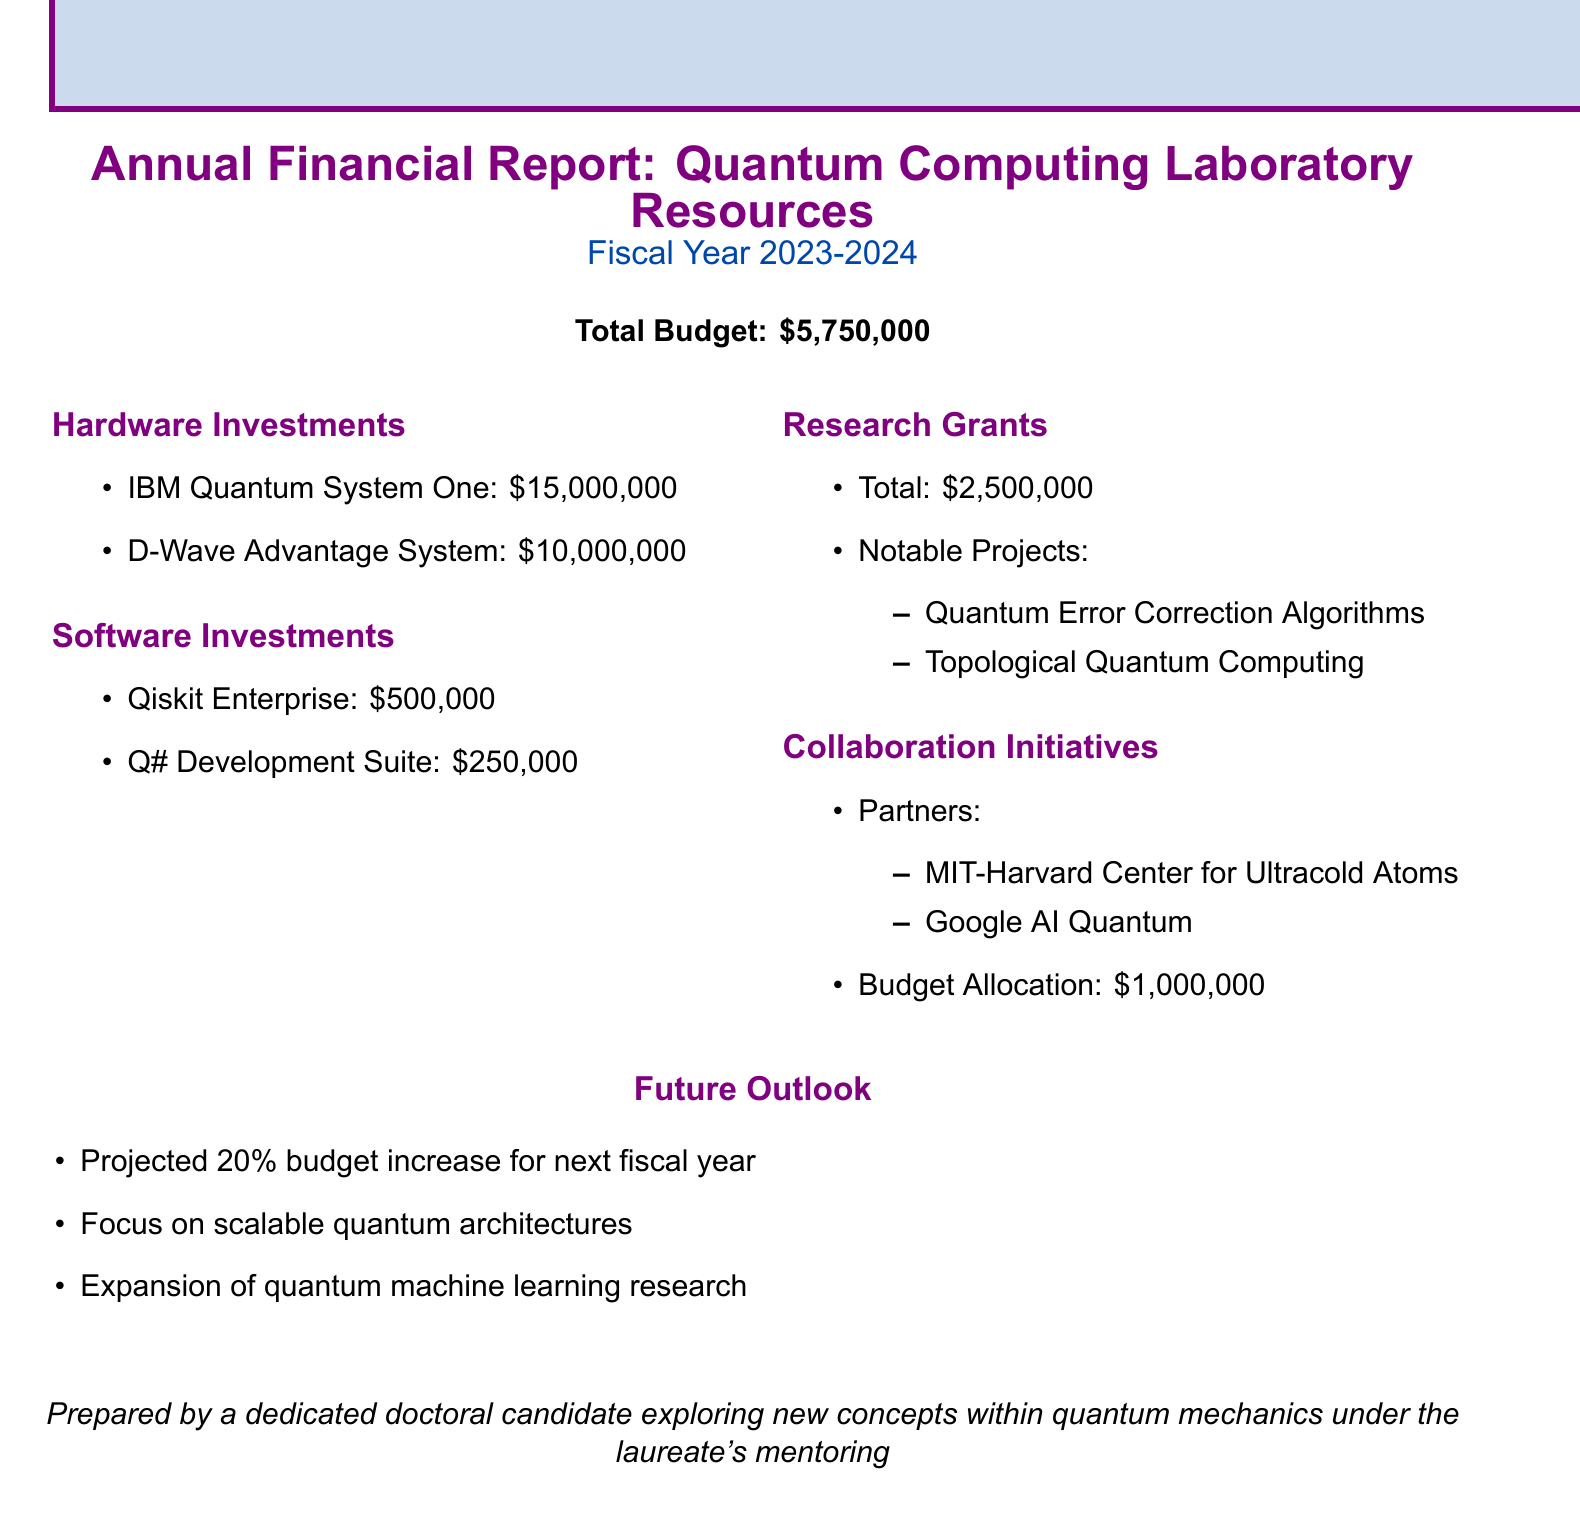What is the total budget? The total budget is specified at the beginning of the document, which sums up to $5,750,000.
Answer: $5,750,000 What is the cost of the IBM Quantum System One? The cost of the IBM Quantum System One is detailed in the Hardware Investments section.
Answer: $15,000,000 What are the notable projects funded by research grants? The notable projects are listed under the Research Grants section.
Answer: Quantum Error Correction Algorithms, Topological Quantum Computing Who are the collaboration partners mentioned? The partners are outlined in the Collaboration Initiatives section of the report.
Answer: MIT-Harvard Center for Ultracold Atoms, Google AI Quantum What is the budget allocation for collaboration initiatives? The budget allocation is clearly mentioned in the respective section of the report.
Answer: $1,000,000 What is the projected budget increase for the next fiscal year? The expected budget increase is provided under the Future Outlook section.
Answer: 20% 